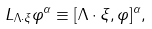<formula> <loc_0><loc_0><loc_500><loc_500>L _ { \Lambda \cdot \xi } \varphi ^ { \alpha } \equiv [ \Lambda \cdot \xi , \varphi ] ^ { \alpha } ,</formula> 